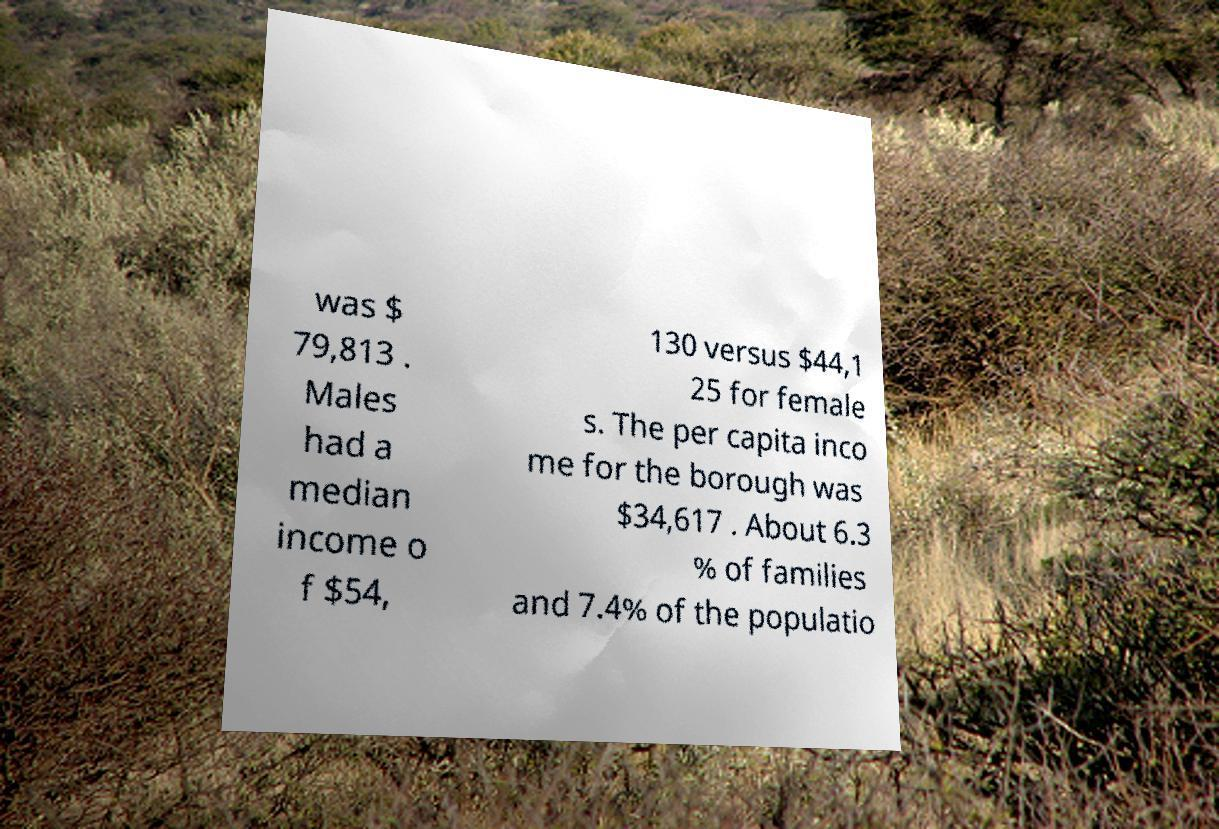What messages or text are displayed in this image? I need them in a readable, typed format. was $ 79,813 . Males had a median income o f $54, 130 versus $44,1 25 for female s. The per capita inco me for the borough was $34,617 . About 6.3 % of families and 7.4% of the populatio 